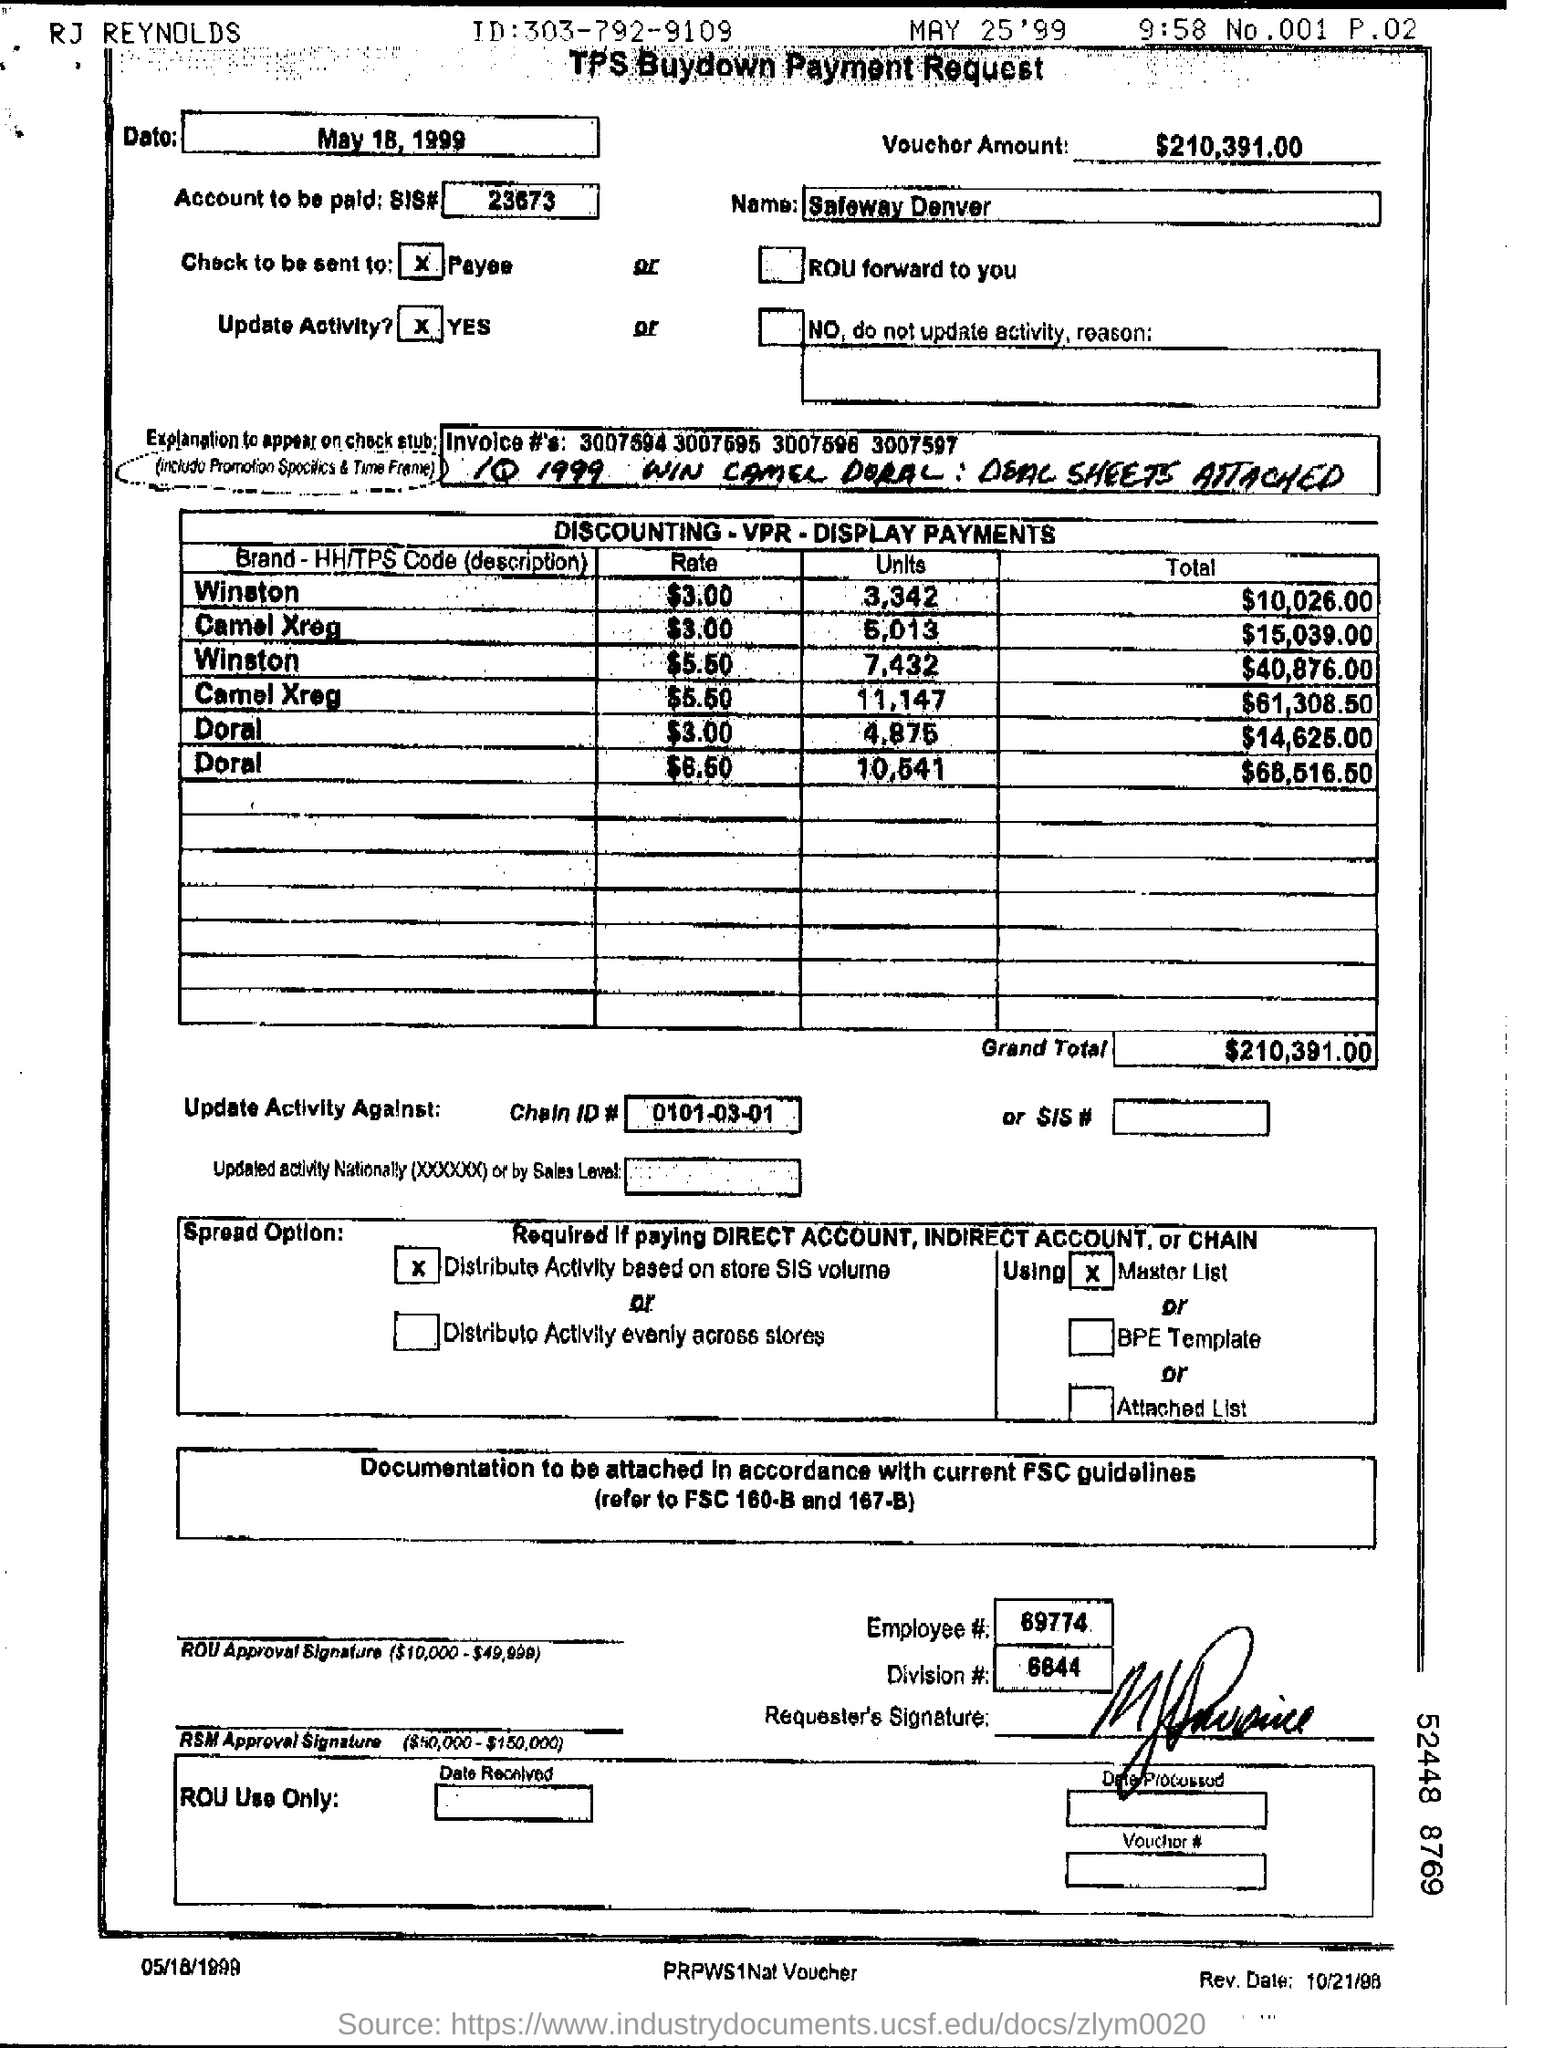What is the Voucher Amount ?
Make the answer very short. $210,391.00. What is chain ID number ?
Make the answer very short. 0101-03-01. 